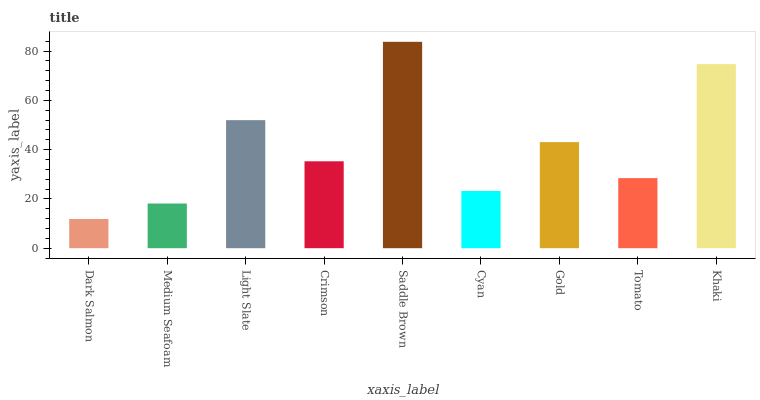Is Dark Salmon the minimum?
Answer yes or no. Yes. Is Saddle Brown the maximum?
Answer yes or no. Yes. Is Medium Seafoam the minimum?
Answer yes or no. No. Is Medium Seafoam the maximum?
Answer yes or no. No. Is Medium Seafoam greater than Dark Salmon?
Answer yes or no. Yes. Is Dark Salmon less than Medium Seafoam?
Answer yes or no. Yes. Is Dark Salmon greater than Medium Seafoam?
Answer yes or no. No. Is Medium Seafoam less than Dark Salmon?
Answer yes or no. No. Is Crimson the high median?
Answer yes or no. Yes. Is Crimson the low median?
Answer yes or no. Yes. Is Light Slate the high median?
Answer yes or no. No. Is Dark Salmon the low median?
Answer yes or no. No. 